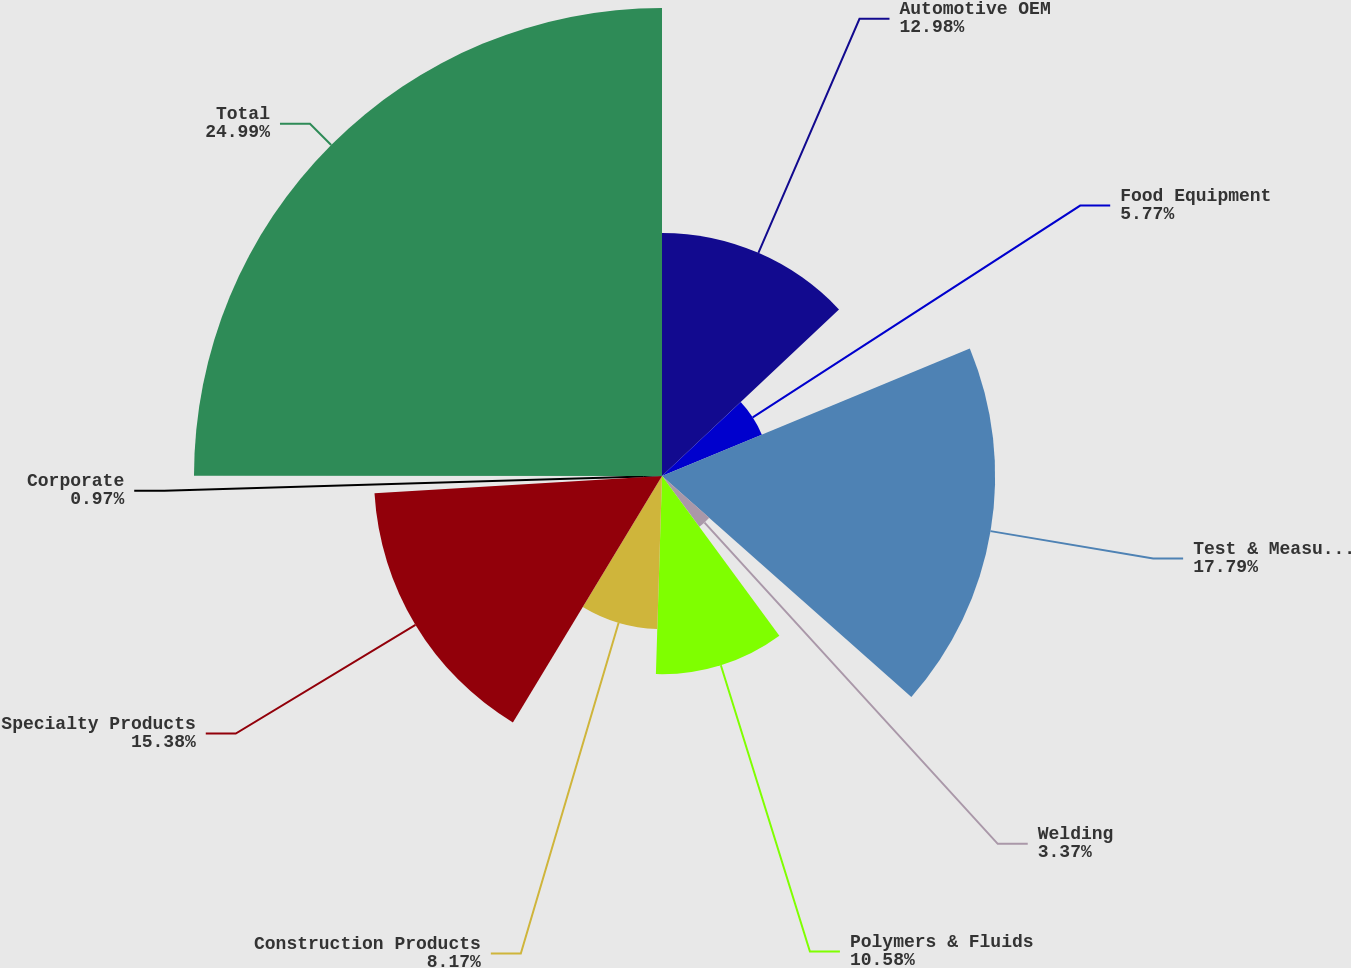Convert chart to OTSL. <chart><loc_0><loc_0><loc_500><loc_500><pie_chart><fcel>Automotive OEM<fcel>Food Equipment<fcel>Test & Measurement and<fcel>Welding<fcel>Polymers & Fluids<fcel>Construction Products<fcel>Specialty Products<fcel>Corporate<fcel>Total<nl><fcel>12.98%<fcel>5.77%<fcel>17.79%<fcel>3.37%<fcel>10.58%<fcel>8.17%<fcel>15.38%<fcel>0.97%<fcel>24.99%<nl></chart> 